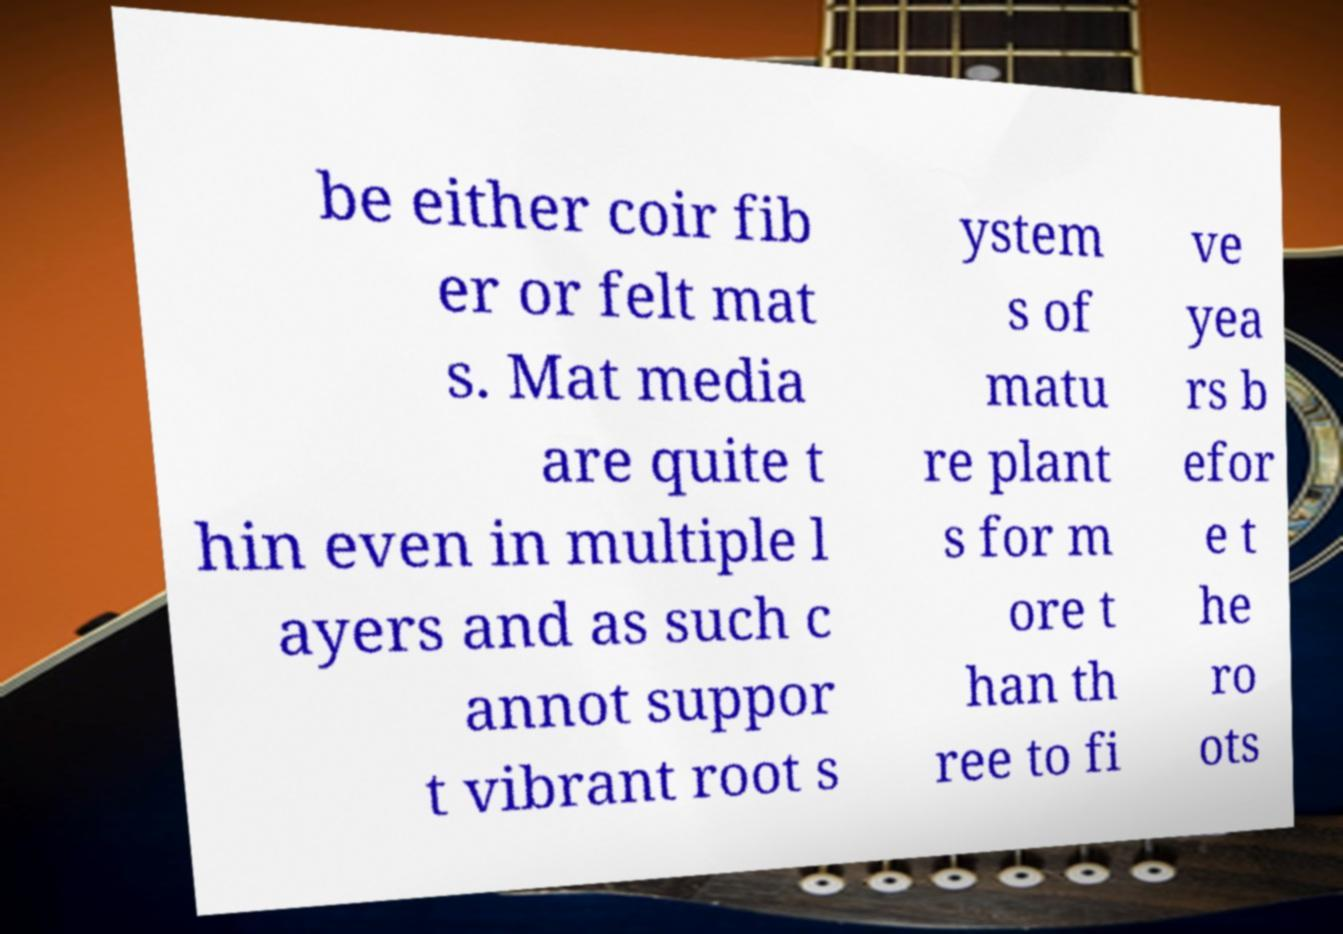Can you read and provide the text displayed in the image?This photo seems to have some interesting text. Can you extract and type it out for me? be either coir fib er or felt mat s. Mat media are quite t hin even in multiple l ayers and as such c annot suppor t vibrant root s ystem s of matu re plant s for m ore t han th ree to fi ve yea rs b efor e t he ro ots 